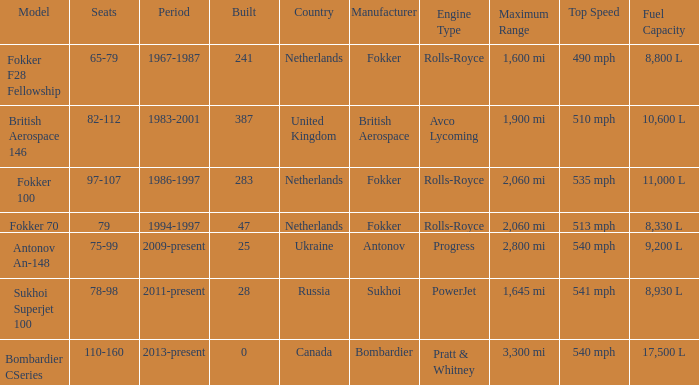How many cabins were built in the time between 1967-1987? 241.0. 